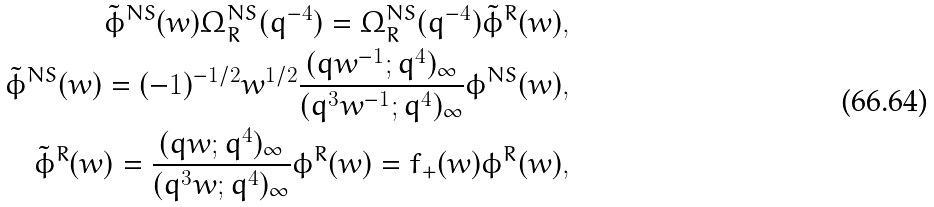Convert formula to latex. <formula><loc_0><loc_0><loc_500><loc_500>\tilde { \phi } ^ { N S } ( w ) \Omega ^ { N S } _ { R } ( q ^ { - 4 } ) = \Omega ^ { N S } _ { R } ( q ^ { - 4 } ) \tilde { \phi } ^ { R } ( w ) , \\ \tilde { \phi } ^ { N S } ( w ) = ( - 1 ) ^ { - 1 / 2 } w ^ { 1 / 2 } \frac { ( q w ^ { - 1 } ; q ^ { 4 } ) _ { \infty } } { ( q ^ { 3 } w ^ { - 1 } ; q ^ { 4 } ) _ { \infty } } \phi ^ { N S } ( w ) , \\ \tilde { \phi } ^ { R } ( w ) = \frac { ( q w ; q ^ { 4 } ) _ { \infty } } { ( q ^ { 3 } w ; q ^ { 4 } ) _ { \infty } } \phi ^ { R } ( w ) = f _ { + } ( w ) \phi ^ { R } ( w ) ,</formula> 